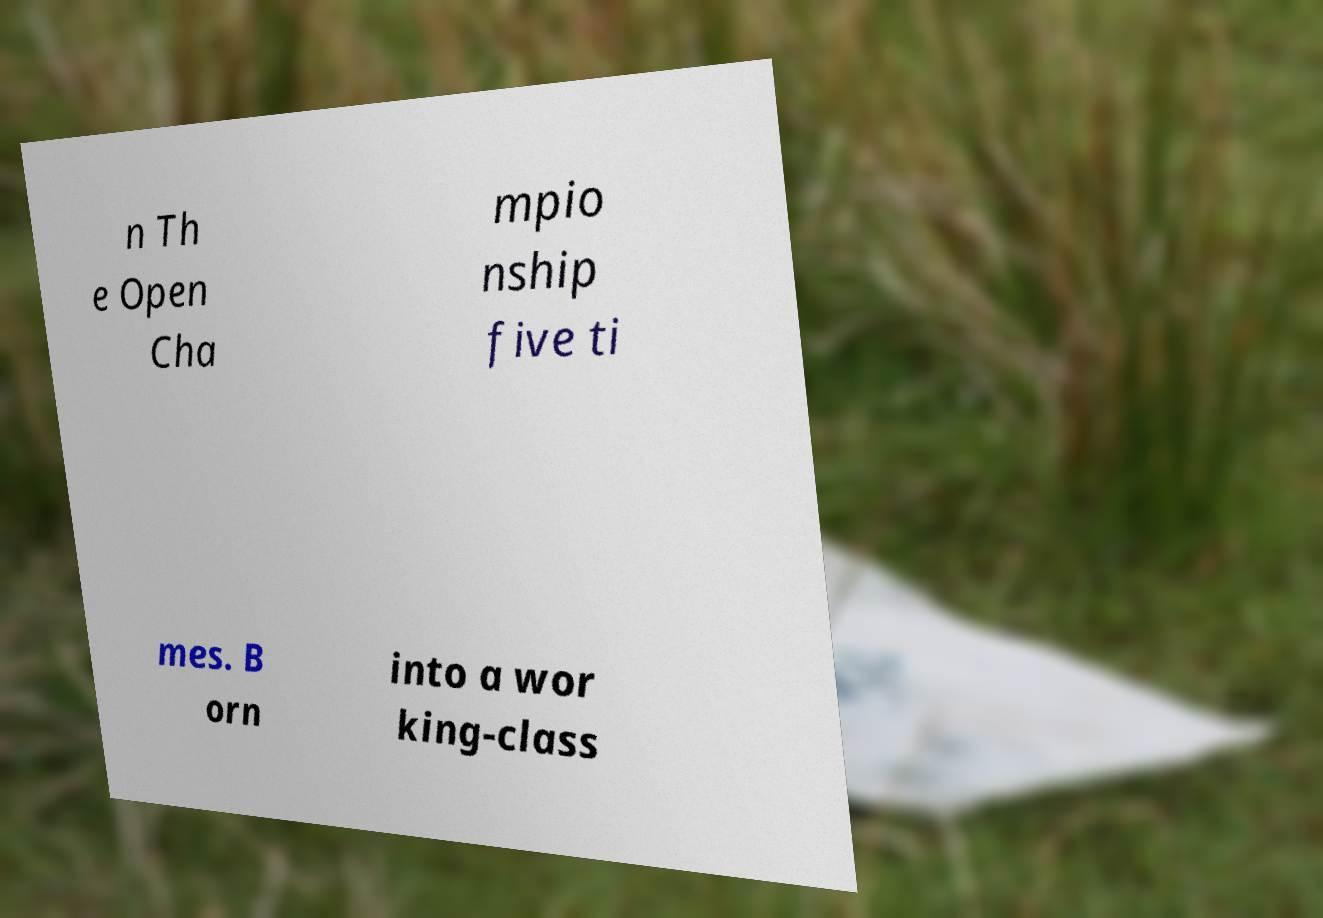Can you read and provide the text displayed in the image?This photo seems to have some interesting text. Can you extract and type it out for me? n Th e Open Cha mpio nship five ti mes. B orn into a wor king-class 